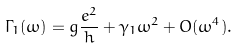<formula> <loc_0><loc_0><loc_500><loc_500>\Gamma _ { 1 } ( \omega ) = g \frac { e ^ { 2 } } { h } + \gamma _ { 1 } \omega ^ { 2 } + O ( \omega ^ { 4 } ) .</formula> 